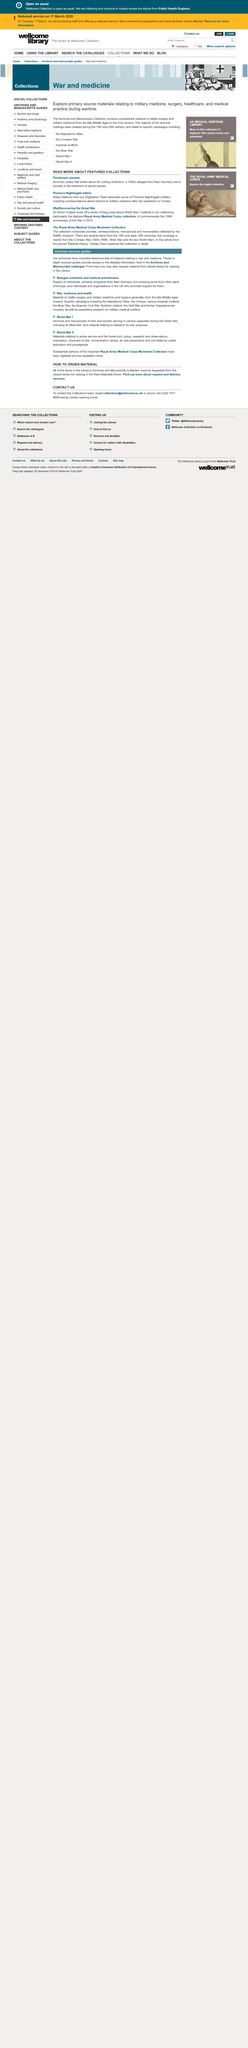Point out several critical features in this image. Lesley Hall writes about Sir Ludwig Guttmann in her work. Rada Vlatkovic, a member of the Digitisation Team, describes some of Florence Nightingale's letters, including correspondence about reforms to military medicine after her expedition to the Crimea. Sir Ludwig Guttmann, a 1930s refugee from Nazi Germany and a pioneer in the treatment of spinal injuries, is recognized as a leading figure in the field of medicine. 